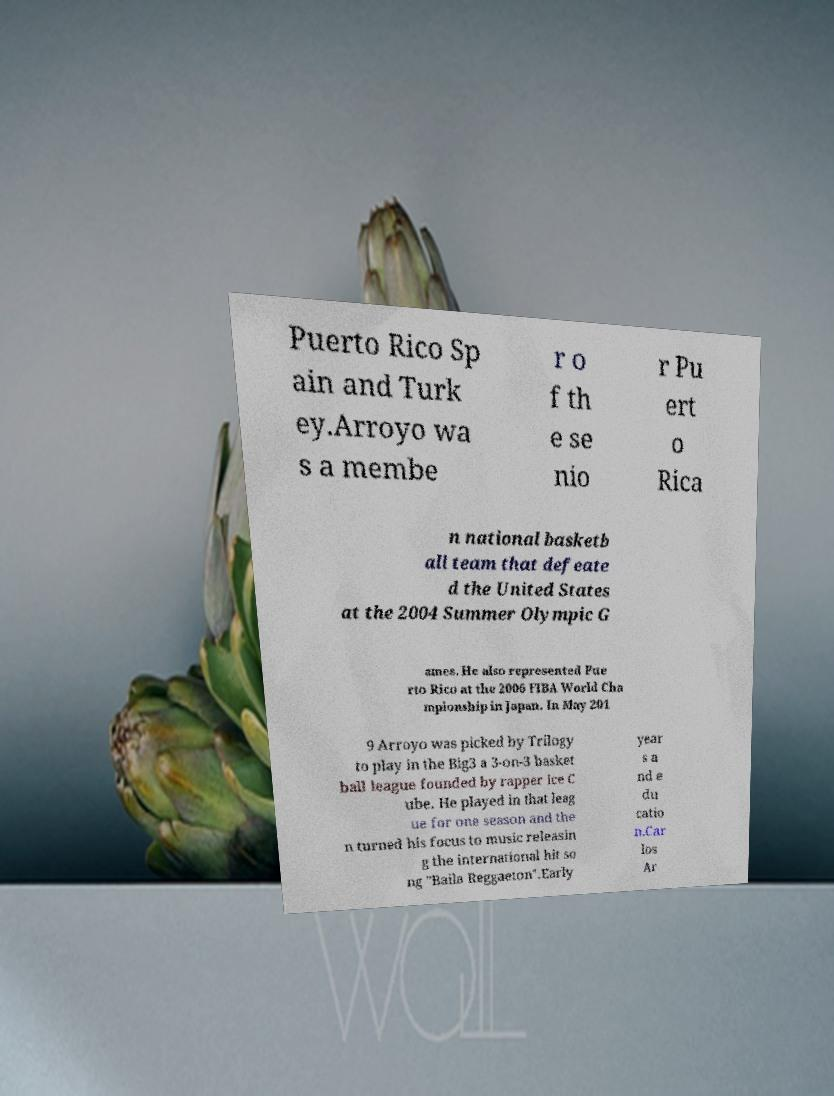For documentation purposes, I need the text within this image transcribed. Could you provide that? Puerto Rico Sp ain and Turk ey.Arroyo wa s a membe r o f th e se nio r Pu ert o Rica n national basketb all team that defeate d the United States at the 2004 Summer Olympic G ames. He also represented Pue rto Rico at the 2006 FIBA World Cha mpionship in Japan. In May 201 9 Arroyo was picked by Trilogy to play in the Big3 a 3-on-3 basket ball league founded by rapper Ice C ube. He played in that leag ue for one season and the n turned his focus to music releasin g the international hit so ng "Baila Reggaeton".Early year s a nd e du catio n.Car los Ar 